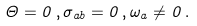<formula> <loc_0><loc_0><loc_500><loc_500>\Theta = 0 \, , \sigma _ { a b } = 0 \, , \omega _ { a } \neq 0 \, .</formula> 